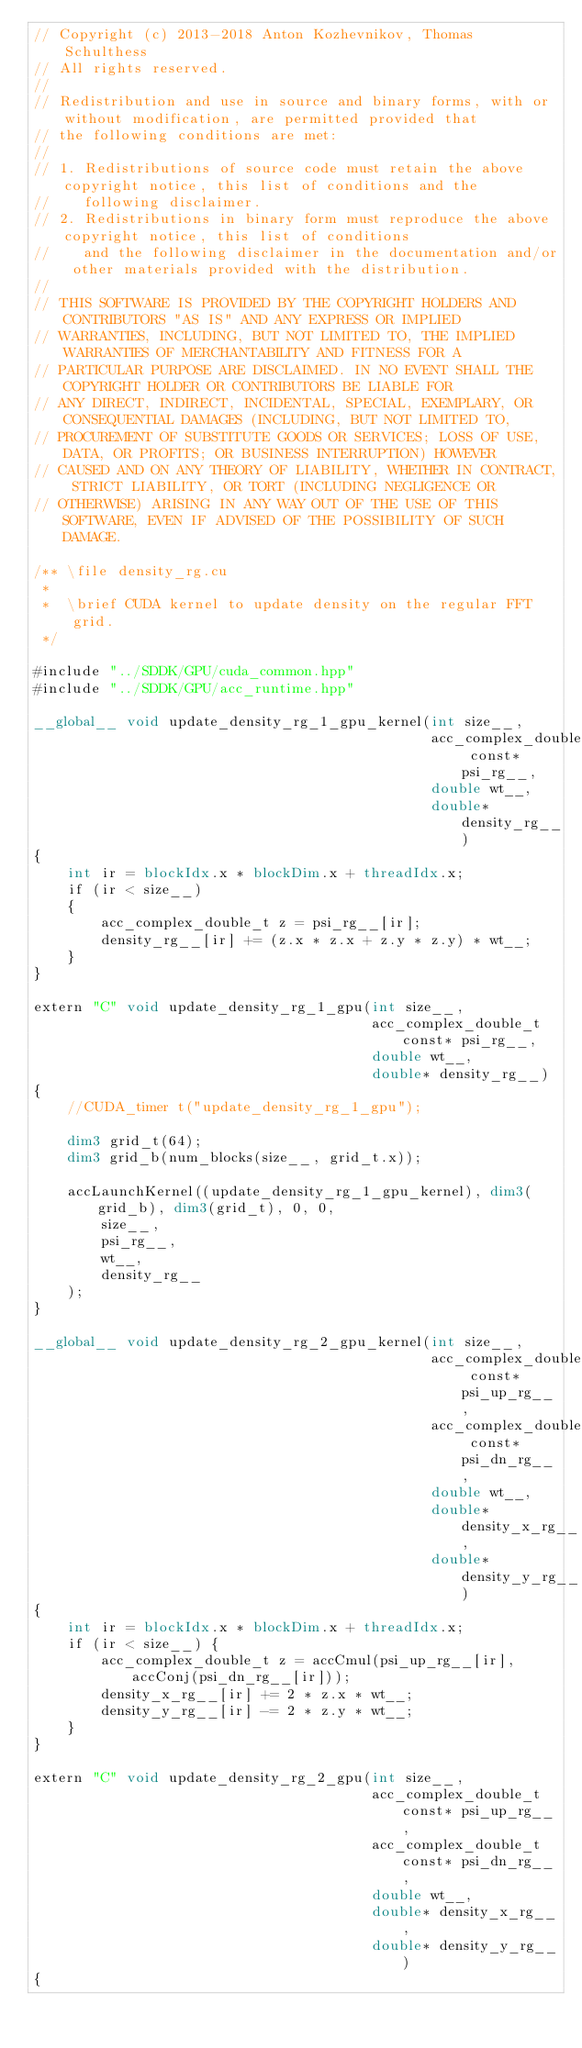Convert code to text. <code><loc_0><loc_0><loc_500><loc_500><_Cuda_>// Copyright (c) 2013-2018 Anton Kozhevnikov, Thomas Schulthess
// All rights reserved.
//
// Redistribution and use in source and binary forms, with or without modification, are permitted provided that
// the following conditions are met:
//
// 1. Redistributions of source code must retain the above copyright notice, this list of conditions and the
//    following disclaimer.
// 2. Redistributions in binary form must reproduce the above copyright notice, this list of conditions
//    and the following disclaimer in the documentation and/or other materials provided with the distribution.
//
// THIS SOFTWARE IS PROVIDED BY THE COPYRIGHT HOLDERS AND CONTRIBUTORS "AS IS" AND ANY EXPRESS OR IMPLIED
// WARRANTIES, INCLUDING, BUT NOT LIMITED TO, THE IMPLIED WARRANTIES OF MERCHANTABILITY AND FITNESS FOR A
// PARTICULAR PURPOSE ARE DISCLAIMED. IN NO EVENT SHALL THE COPYRIGHT HOLDER OR CONTRIBUTORS BE LIABLE FOR
// ANY DIRECT, INDIRECT, INCIDENTAL, SPECIAL, EXEMPLARY, OR CONSEQUENTIAL DAMAGES (INCLUDING, BUT NOT LIMITED TO,
// PROCUREMENT OF SUBSTITUTE GOODS OR SERVICES; LOSS OF USE, DATA, OR PROFITS; OR BUSINESS INTERRUPTION) HOWEVER
// CAUSED AND ON ANY THEORY OF LIABILITY, WHETHER IN CONTRACT, STRICT LIABILITY, OR TORT (INCLUDING NEGLIGENCE OR
// OTHERWISE) ARISING IN ANY WAY OUT OF THE USE OF THIS SOFTWARE, EVEN IF ADVISED OF THE POSSIBILITY OF SUCH DAMAGE.

/** \file density_rg.cu
 *
 *  \brief CUDA kernel to update density on the regular FFT grid.
 */

#include "../SDDK/GPU/cuda_common.hpp"
#include "../SDDK/GPU/acc_runtime.hpp"

__global__ void update_density_rg_1_gpu_kernel(int size__,
                                               acc_complex_double_t const* psi_rg__,
                                               double wt__,
                                               double* density_rg__)
{
    int ir = blockIdx.x * blockDim.x + threadIdx.x;
    if (ir < size__)
    {
        acc_complex_double_t z = psi_rg__[ir];
        density_rg__[ir] += (z.x * z.x + z.y * z.y) * wt__;
    }
}

extern "C" void update_density_rg_1_gpu(int size__, 
                                        acc_complex_double_t const* psi_rg__, 
                                        double wt__, 
                                        double* density_rg__)
{
    //CUDA_timer t("update_density_rg_1_gpu");

    dim3 grid_t(64);
    dim3 grid_b(num_blocks(size__, grid_t.x));

    accLaunchKernel((update_density_rg_1_gpu_kernel), dim3(grid_b), dim3(grid_t), 0, 0, 
        size__,
        psi_rg__,
        wt__,
        density_rg__
    );
}

__global__ void update_density_rg_2_gpu_kernel(int size__,
                                               acc_complex_double_t const* psi_up_rg__,
                                               acc_complex_double_t const* psi_dn_rg__,
                                               double wt__,
                                               double* density_x_rg__,
                                               double* density_y_rg__)
{
    int ir = blockIdx.x * blockDim.x + threadIdx.x;
    if (ir < size__) {
        acc_complex_double_t z = accCmul(psi_up_rg__[ir], accConj(psi_dn_rg__[ir]));
        density_x_rg__[ir] += 2 * z.x * wt__;
        density_y_rg__[ir] -= 2 * z.y * wt__;
    }
}

extern "C" void update_density_rg_2_gpu(int size__, 
                                        acc_complex_double_t const* psi_up_rg__, 
                                        acc_complex_double_t const* psi_dn_rg__, 
                                        double wt__, 
                                        double* density_x_rg__,
                                        double* density_y_rg__)
{</code> 